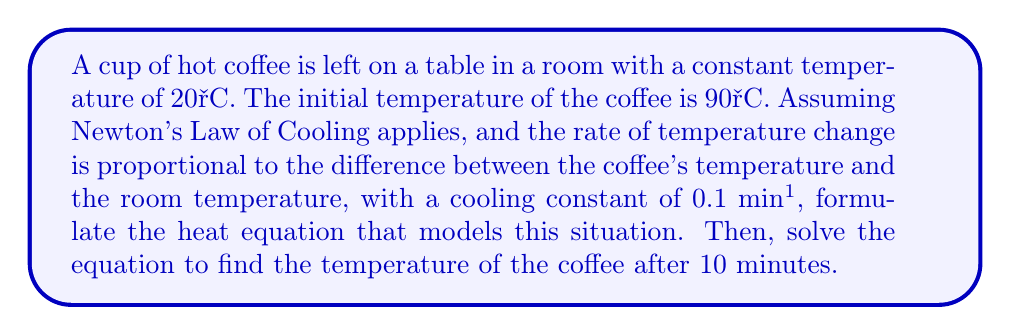Help me with this question. Let's approach this step-by-step:

1) First, we need to set up the heat equation. According to Newton's Law of Cooling:

   $$\frac{dT}{dt} = -k(T - T_r)$$

   Where:
   $T$ is the temperature of the coffee
   $T_r$ is the room temperature
   $k$ is the cooling constant
   $t$ is time

2) We're given:
   $T_r = 20°C$
   Initial $T = 90°C$
   $k = 0.1$ min⁻¹

3) Substituting these values into our equation:

   $$\frac{dT}{dt} = -0.1(T - 20)$$

4) To solve this differential equation, we can separate variables:

   $$\frac{dT}{T - 20} = -0.1dt$$

5) Integrating both sides:

   $$\int \frac{dT}{T - 20} = -0.1 \int dt$$

   $$\ln|T - 20| = -0.1t + C$$

6) Using the initial condition $T = 90°C$ at $t = 0$:

   $$\ln|90 - 20| = C$$
   $$C = \ln70$$

7) Substituting back:

   $$\ln|T - 20| = -0.1t + \ln70$$

8) Solving for $T$:

   $$T - 20 = 70e^{-0.1t}$$
   $$T = 70e^{-0.1t} + 20$$

9) To find the temperature after 10 minutes, we substitute $t = 10$:

   $$T = 70e^{-0.1(10)} + 20$$
   $$T = 70e^{-1} + 20$$
   $$T \approx 45.7°C$$
Answer: $T = 70e^{-0.1t} + 20$; After 10 minutes, $T \approx 45.7°C$ 